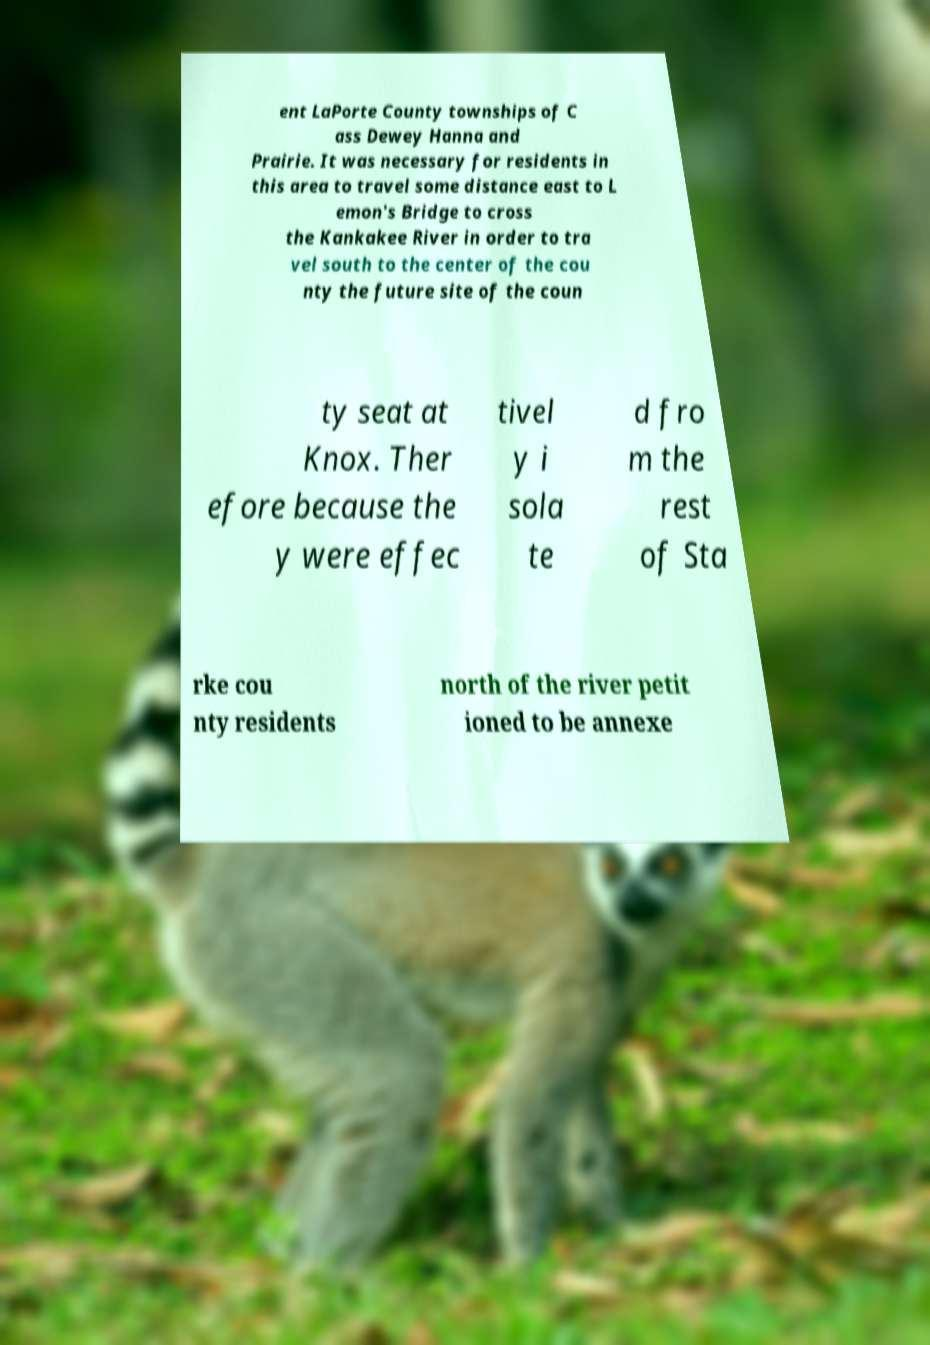Can you accurately transcribe the text from the provided image for me? ent LaPorte County townships of C ass Dewey Hanna and Prairie. It was necessary for residents in this area to travel some distance east to L emon's Bridge to cross the Kankakee River in order to tra vel south to the center of the cou nty the future site of the coun ty seat at Knox. Ther efore because the y were effec tivel y i sola te d fro m the rest of Sta rke cou nty residents north of the river petit ioned to be annexe 